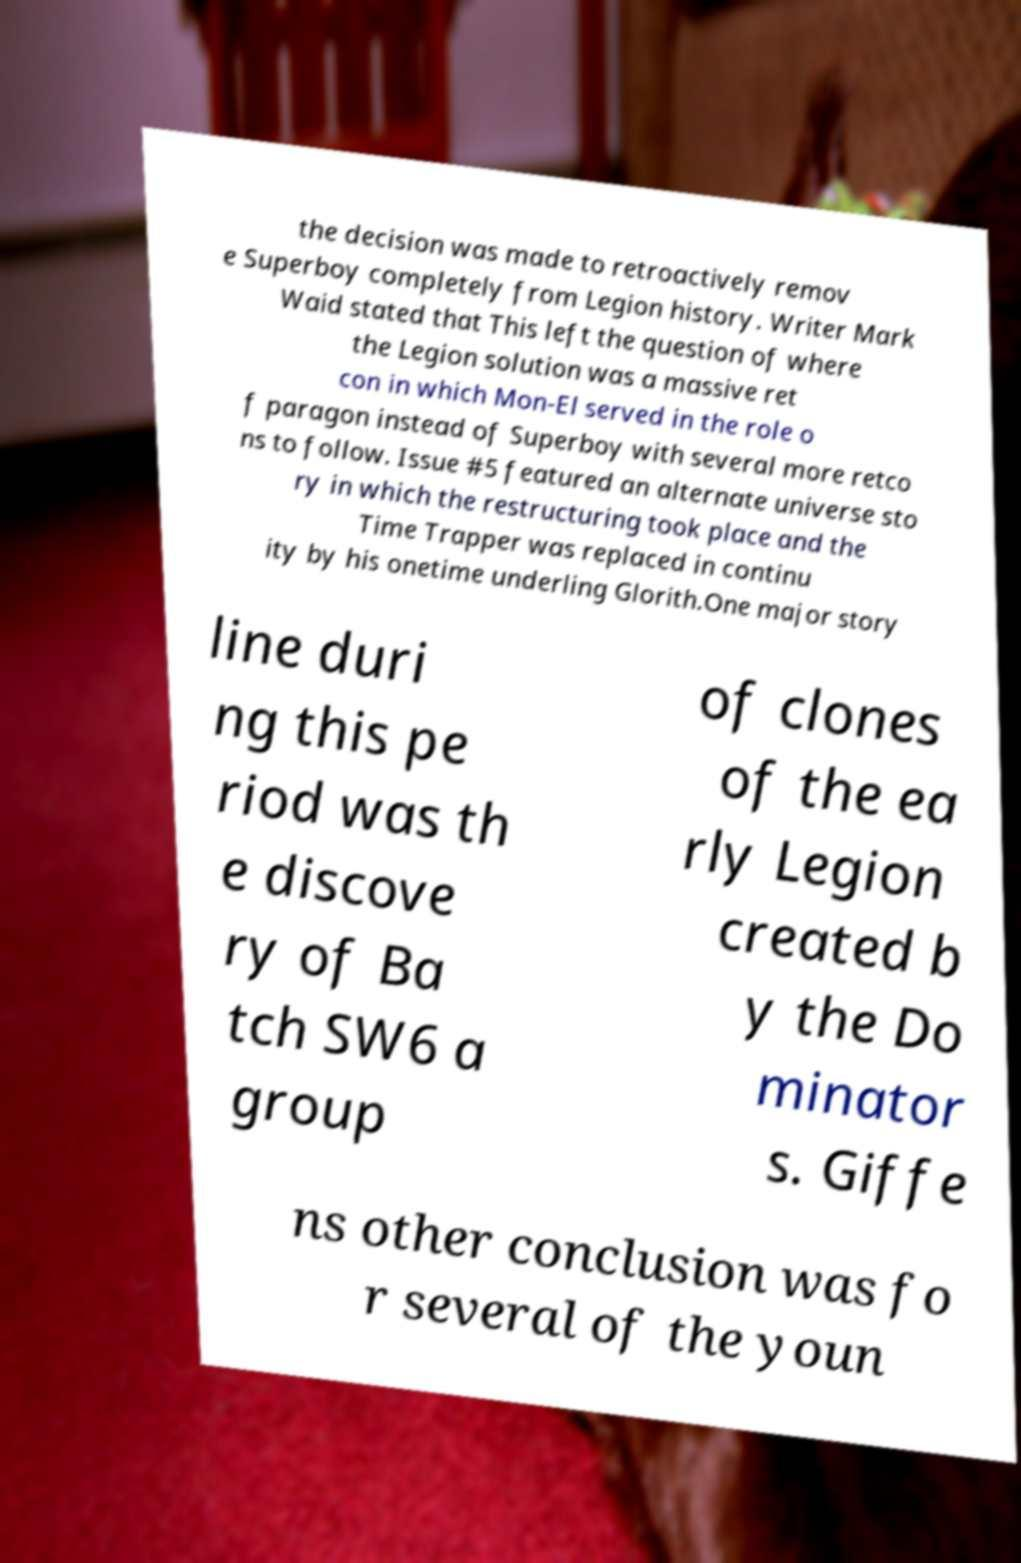For documentation purposes, I need the text within this image transcribed. Could you provide that? the decision was made to retroactively remov e Superboy completely from Legion history. Writer Mark Waid stated that This left the question of where the Legion solution was a massive ret con in which Mon-El served in the role o f paragon instead of Superboy with several more retco ns to follow. Issue #5 featured an alternate universe sto ry in which the restructuring took place and the Time Trapper was replaced in continu ity by his onetime underling Glorith.One major story line duri ng this pe riod was th e discove ry of Ba tch SW6 a group of clones of the ea rly Legion created b y the Do minator s. Giffe ns other conclusion was fo r several of the youn 